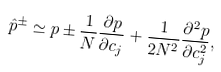<formula> <loc_0><loc_0><loc_500><loc_500>\hat { p } ^ { \pm } \simeq p \pm \frac { 1 } { N } \frac { \partial { p } } { \partial { c _ { j } } } + \frac { 1 } { 2 N ^ { 2 } } \frac { \partial ^ { 2 } { p } } { \partial { c _ { j } ^ { 2 } } } ,</formula> 